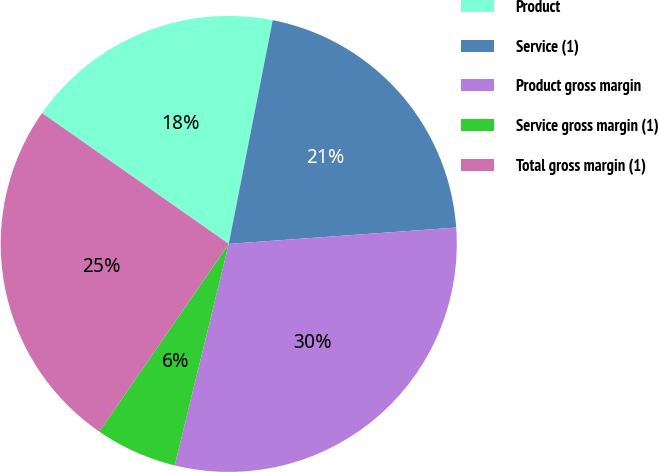<chart> <loc_0><loc_0><loc_500><loc_500><pie_chart><fcel>Product<fcel>Service (1)<fcel>Product gross margin<fcel>Service gross margin (1)<fcel>Total gross margin (1)<nl><fcel>18.36%<fcel>20.77%<fcel>29.95%<fcel>5.8%<fcel>25.12%<nl></chart> 